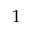Convert formula to latex. <formula><loc_0><loc_0><loc_500><loc_500>1</formula> 